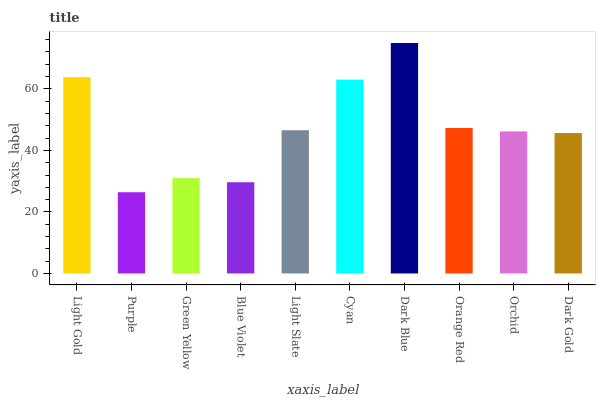Is Purple the minimum?
Answer yes or no. Yes. Is Dark Blue the maximum?
Answer yes or no. Yes. Is Green Yellow the minimum?
Answer yes or no. No. Is Green Yellow the maximum?
Answer yes or no. No. Is Green Yellow greater than Purple?
Answer yes or no. Yes. Is Purple less than Green Yellow?
Answer yes or no. Yes. Is Purple greater than Green Yellow?
Answer yes or no. No. Is Green Yellow less than Purple?
Answer yes or no. No. Is Light Slate the high median?
Answer yes or no. Yes. Is Orchid the low median?
Answer yes or no. Yes. Is Dark Blue the high median?
Answer yes or no. No. Is Blue Violet the low median?
Answer yes or no. No. 